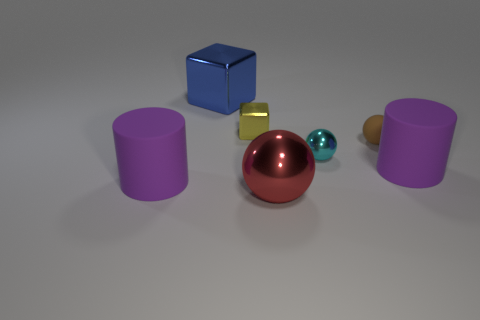How big is the yellow block on the left side of the tiny brown object?
Offer a very short reply. Small. There is a cyan object that is the same size as the brown sphere; what is it made of?
Offer a very short reply. Metal. Does the tiny cyan thing have the same shape as the big red metallic thing?
Make the answer very short. Yes. How many objects are either large purple things or tiny shiny things that are left of the red shiny ball?
Give a very brief answer. 3. There is a purple object that is on the left side of the red thing; is its size the same as the matte sphere?
Make the answer very short. No. How many purple cylinders are left of the large purple rubber cylinder right of the cylinder left of the blue block?
Keep it short and to the point. 1. How many green objects are cylinders or matte things?
Give a very brief answer. 0. The tiny sphere that is made of the same material as the tiny yellow thing is what color?
Your answer should be very brief. Cyan. What number of large objects are either blocks or blue metal cubes?
Make the answer very short. 1. Are there fewer large purple rubber objects than rubber things?
Your answer should be very brief. Yes. 